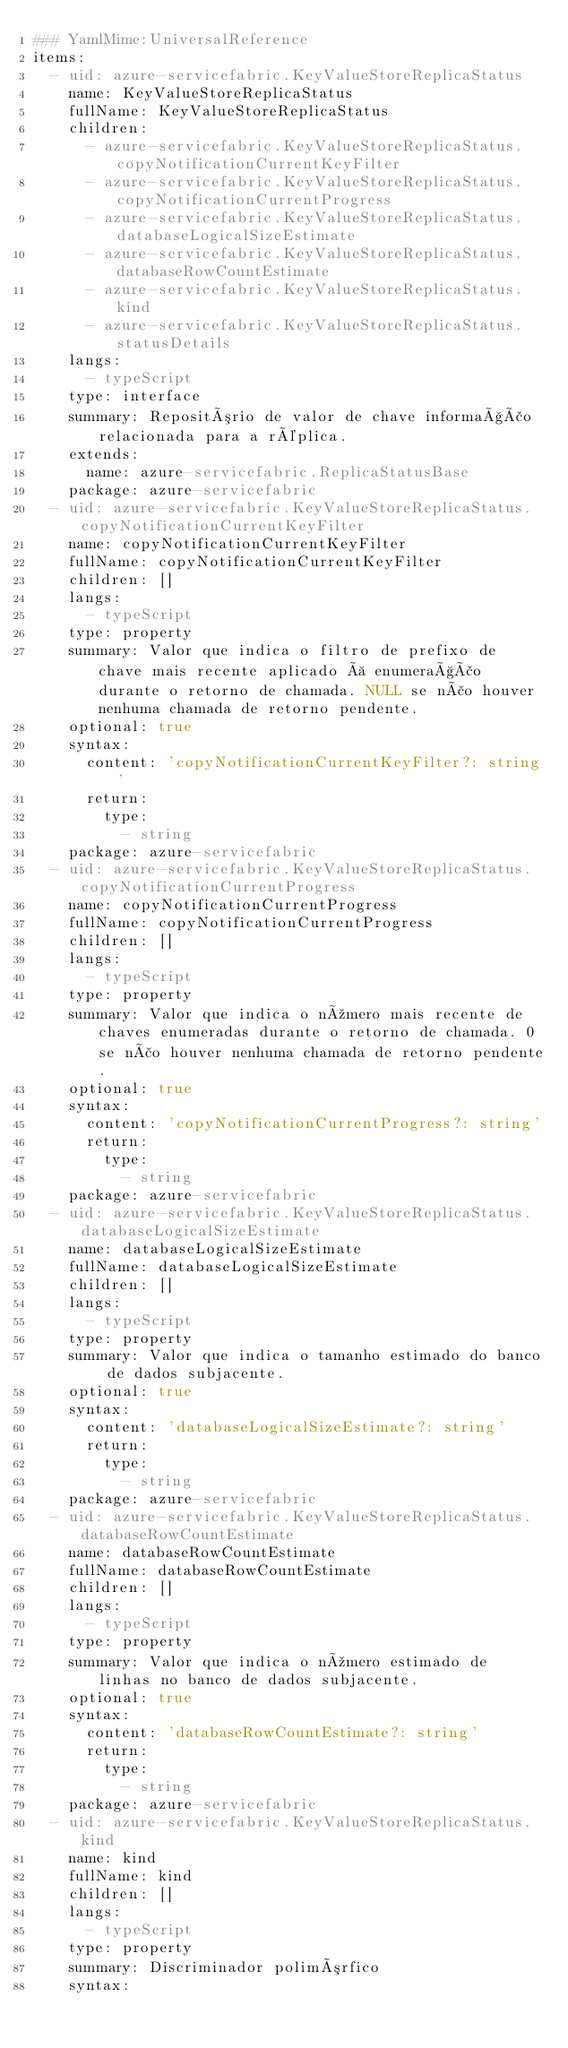<code> <loc_0><loc_0><loc_500><loc_500><_YAML_>### YamlMime:UniversalReference
items:
  - uid: azure-servicefabric.KeyValueStoreReplicaStatus
    name: KeyValueStoreReplicaStatus
    fullName: KeyValueStoreReplicaStatus
    children:
      - azure-servicefabric.KeyValueStoreReplicaStatus.copyNotificationCurrentKeyFilter
      - azure-servicefabric.KeyValueStoreReplicaStatus.copyNotificationCurrentProgress
      - azure-servicefabric.KeyValueStoreReplicaStatus.databaseLogicalSizeEstimate
      - azure-servicefabric.KeyValueStoreReplicaStatus.databaseRowCountEstimate
      - azure-servicefabric.KeyValueStoreReplicaStatus.kind
      - azure-servicefabric.KeyValueStoreReplicaStatus.statusDetails
    langs:
      - typeScript
    type: interface
    summary: Repositório de valor de chave informação relacionada para a réplica.
    extends:
      name: azure-servicefabric.ReplicaStatusBase
    package: azure-servicefabric
  - uid: azure-servicefabric.KeyValueStoreReplicaStatus.copyNotificationCurrentKeyFilter
    name: copyNotificationCurrentKeyFilter
    fullName: copyNotificationCurrentKeyFilter
    children: []
    langs:
      - typeScript
    type: property
    summary: Valor que indica o filtro de prefixo de chave mais recente aplicado à enumeração durante o retorno de chamada. NULL se não houver nenhuma chamada de retorno pendente.
    optional: true
    syntax:
      content: 'copyNotificationCurrentKeyFilter?: string'
      return:
        type:
          - string
    package: azure-servicefabric
  - uid: azure-servicefabric.KeyValueStoreReplicaStatus.copyNotificationCurrentProgress
    name: copyNotificationCurrentProgress
    fullName: copyNotificationCurrentProgress
    children: []
    langs:
      - typeScript
    type: property
    summary: Valor que indica o número mais recente de chaves enumeradas durante o retorno de chamada. 0 se não houver nenhuma chamada de retorno pendente.
    optional: true
    syntax:
      content: 'copyNotificationCurrentProgress?: string'
      return:
        type:
          - string
    package: azure-servicefabric
  - uid: azure-servicefabric.KeyValueStoreReplicaStatus.databaseLogicalSizeEstimate
    name: databaseLogicalSizeEstimate
    fullName: databaseLogicalSizeEstimate
    children: []
    langs:
      - typeScript
    type: property
    summary: Valor que indica o tamanho estimado do banco de dados subjacente.
    optional: true
    syntax:
      content: 'databaseLogicalSizeEstimate?: string'
      return:
        type:
          - string
    package: azure-servicefabric
  - uid: azure-servicefabric.KeyValueStoreReplicaStatus.databaseRowCountEstimate
    name: databaseRowCountEstimate
    fullName: databaseRowCountEstimate
    children: []
    langs:
      - typeScript
    type: property
    summary: Valor que indica o número estimado de linhas no banco de dados subjacente.
    optional: true
    syntax:
      content: 'databaseRowCountEstimate?: string'
      return:
        type:
          - string
    package: azure-servicefabric
  - uid: azure-servicefabric.KeyValueStoreReplicaStatus.kind
    name: kind
    fullName: kind
    children: []
    langs:
      - typeScript
    type: property
    summary: Discriminador polimórfico
    syntax:</code> 